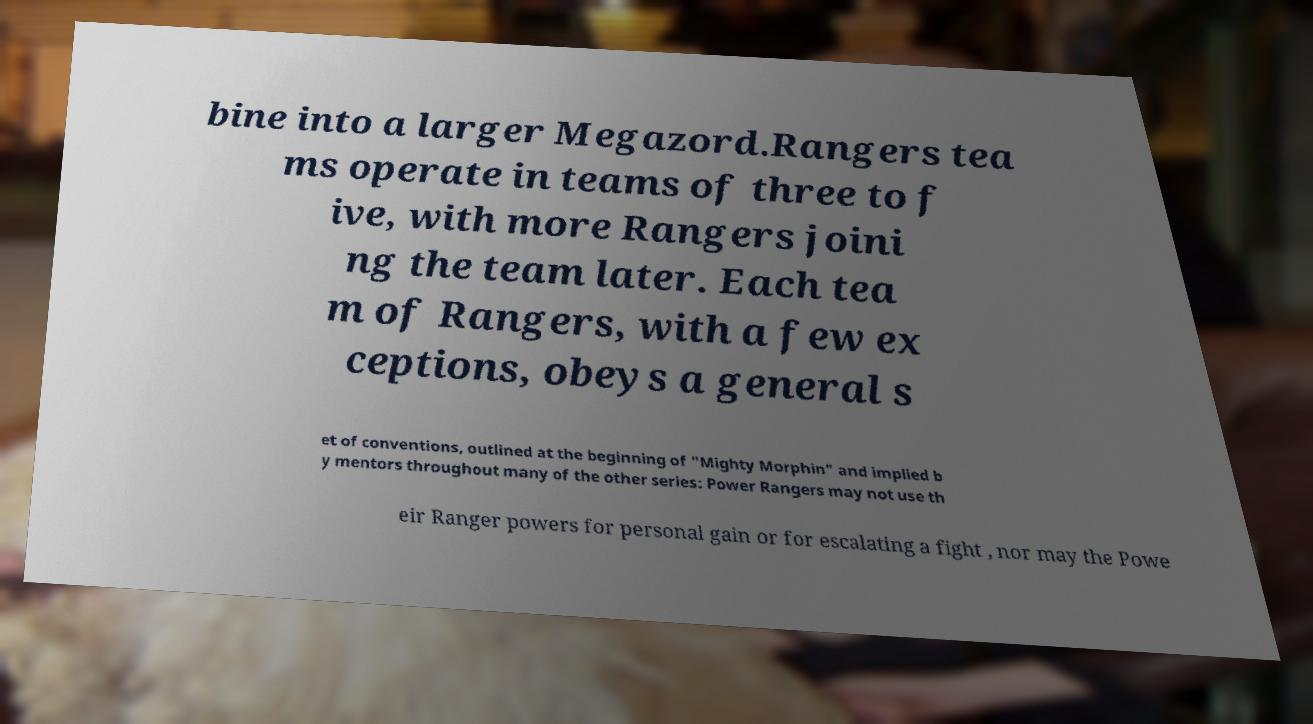For documentation purposes, I need the text within this image transcribed. Could you provide that? bine into a larger Megazord.Rangers tea ms operate in teams of three to f ive, with more Rangers joini ng the team later. Each tea m of Rangers, with a few ex ceptions, obeys a general s et of conventions, outlined at the beginning of "Mighty Morphin" and implied b y mentors throughout many of the other series: Power Rangers may not use th eir Ranger powers for personal gain or for escalating a fight , nor may the Powe 